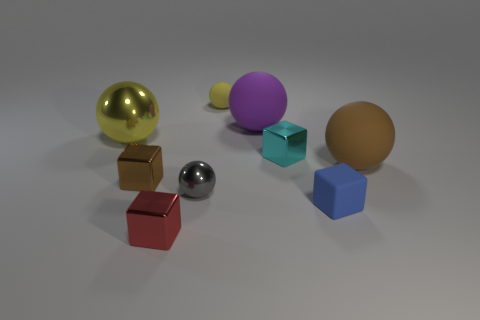Subtract all small metallic cubes. How many cubes are left? 1 Add 1 small shiny objects. How many objects exist? 10 Subtract all blue cylinders. How many yellow balls are left? 2 Subtract 1 balls. How many balls are left? 4 Subtract all yellow balls. How many balls are left? 3 Subtract 1 brown cubes. How many objects are left? 8 Subtract all blocks. How many objects are left? 5 Subtract all purple blocks. Subtract all purple balls. How many blocks are left? 4 Subtract all tiny shiny objects. Subtract all small rubber cubes. How many objects are left? 4 Add 4 large objects. How many large objects are left? 7 